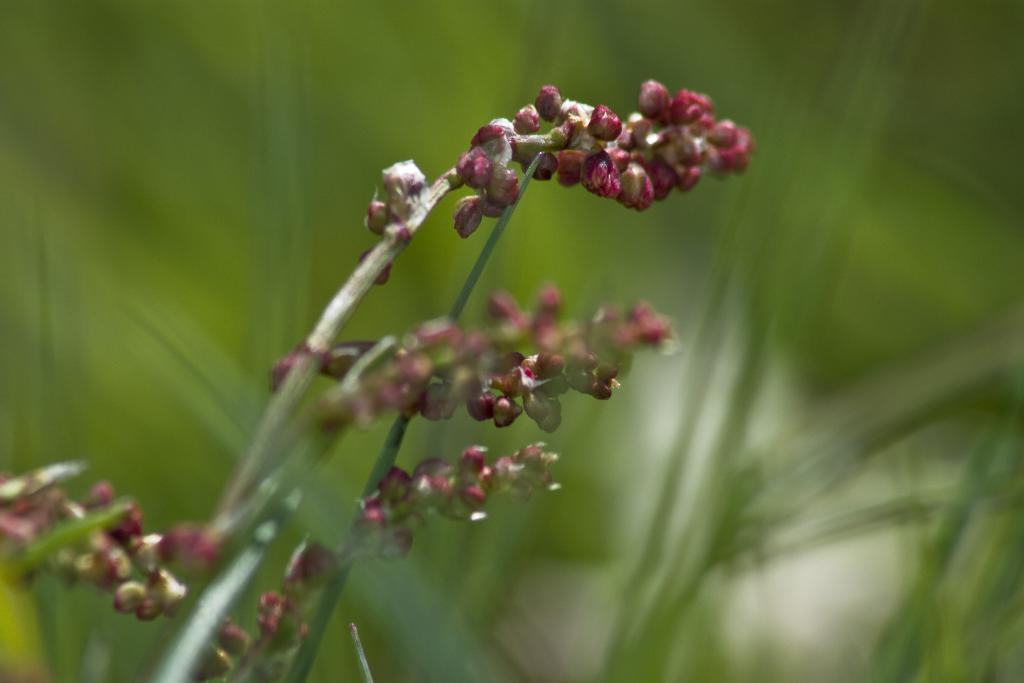What stage of growth are the plants in the image at? The plants in the image have buds on their stems, indicating that they are in the early stages of growth. What verse is being recited by the bird in the image? There is no bird present in the image, and therefore no verse being recited. 